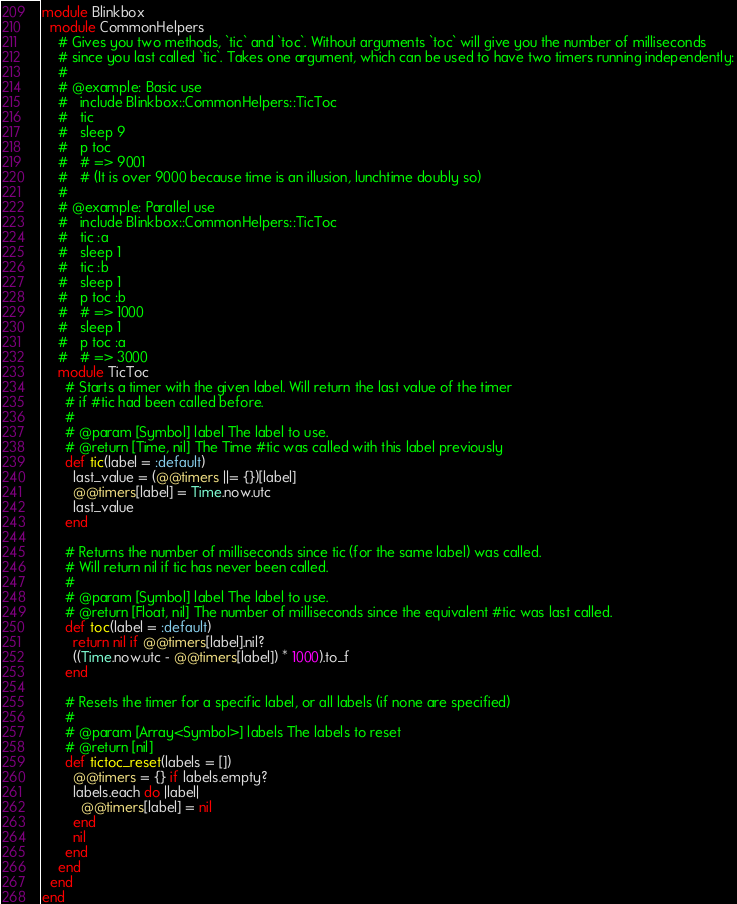<code> <loc_0><loc_0><loc_500><loc_500><_Ruby_>module Blinkbox
  module CommonHelpers
    # Gives you two methods, `tic` and `toc`. Without arguments `toc` will give you the number of milliseconds
    # since you last called `tic`. Takes one argument, which can be used to have two timers running independently:
    #
    # @example: Basic use
    #   include Blinkbox::CommonHelpers::TicToc
    #   tic
    #   sleep 9
    #   p toc
    #   # => 9001
    #   # (It is over 9000 because time is an illusion, lunchtime doubly so)
    #
    # @example: Parallel use
    #   include Blinkbox::CommonHelpers::TicToc
    #   tic :a
    #   sleep 1
    #   tic :b
    #   sleep 1
    #   p toc :b
    #   # => 1000
    #   sleep 1
    #   p toc :a
    #   # => 3000
    module TicToc
      # Starts a timer with the given label. Will return the last value of the timer
      # if #tic had been called before.
      #
      # @param [Symbol] label The label to use.
      # @return [Time, nil] The Time #tic was called with this label previously
      def tic(label = :default)
        last_value = (@@timers ||= {})[label]
        @@timers[label] = Time.now.utc
        last_value
      end

      # Returns the number of milliseconds since tic (for the same label) was called.
      # Will return nil if tic has never been called.
      #
      # @param [Symbol] label The label to use.
      # @return [Float, nil] The number of milliseconds since the equivalent #tic was last called.
      def toc(label = :default)
        return nil if @@timers[label].nil?
        ((Time.now.utc - @@timers[label]) * 1000).to_f
      end

      # Resets the timer for a specific label, or all labels (if none are specified)
      #
      # @param [Array<Symbol>] labels The labels to reset
      # @return [nil]
      def tictoc_reset(labels = [])
        @@timers = {} if labels.empty?
        labels.each do |label|
          @@timers[label] = nil
        end
        nil
      end
    end
  end
end</code> 